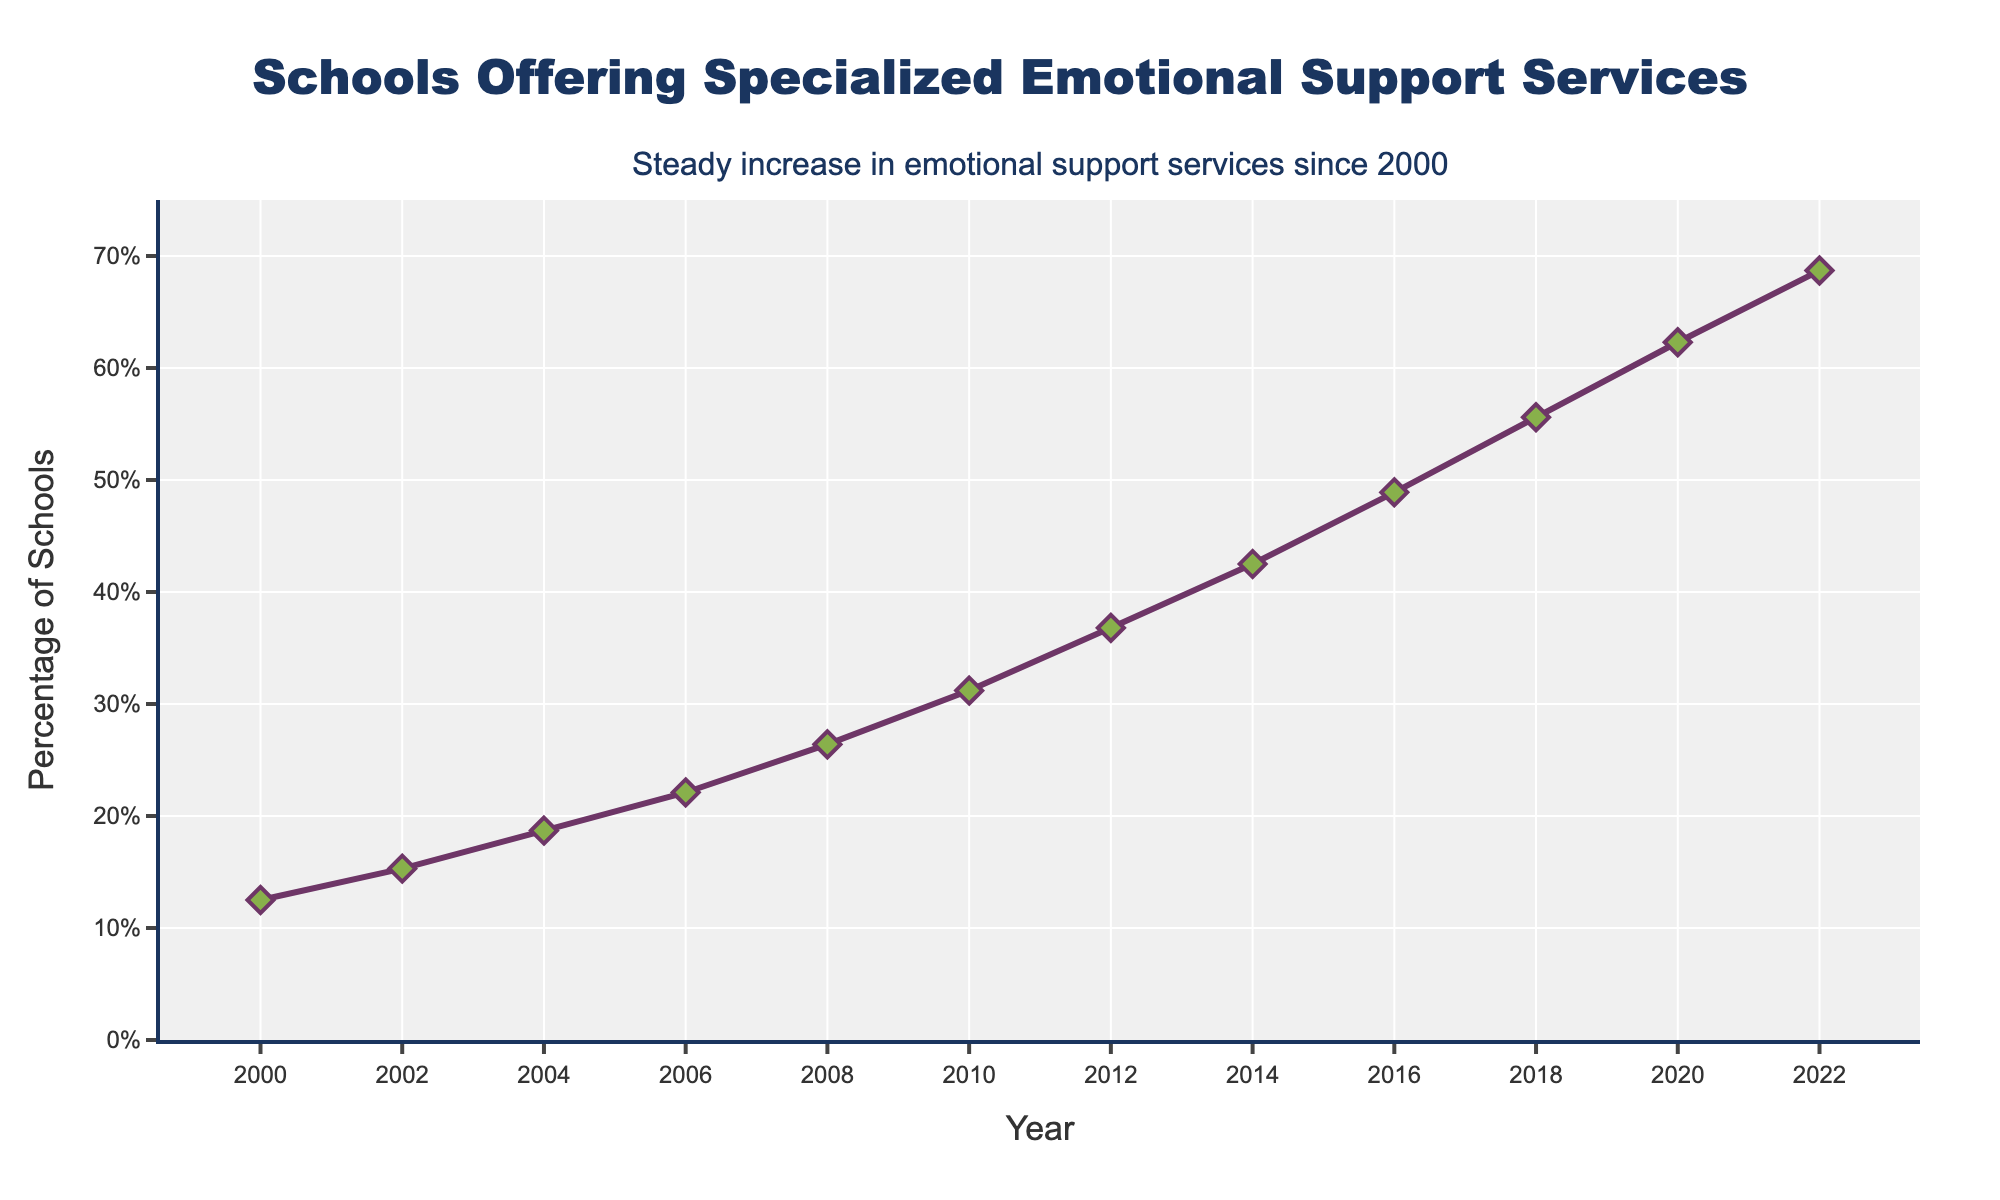What is the percentage of schools offering specialized emotional support services in 2010? Look at the data point corresponding to the year 2010 on the X-axis. The Y-axis value at that point indicates the percentage.
Answer: 31.2% By how many percentage points did the number of schools offering specialized emotional support services increase from 2000 to 2010? Subtract the percentage value in 2000 from the percentage value in 2010. That is 31.2% - 12.5%.
Answer: 18.7% What was the largest year-over-year increase in the percentage of schools offering specialized emotional support services? Identify the years with the largest difference by comparing the percentage values year over year. The largest increase over any two years occurs between 2016 and 2018 (55.6% - 48.9%).
Answer: Between 2016 and 2018 Which year shows the first data point where more than half of the schools offer specialized emotional support services? Locate the point on the graph where the percentage exceeds 50%. This occurs first in 2018.
Answer: 2018 How much did the percentage of schools offering specialized emotional support services increase from 2004 to 2012? Subtract the percentage of schools in 2004 from the percentage in 2012 (36.8% - 18.7%).
Answer: 18.1% What is the difference in the percentage of schools offering specialized emotional support services between 2020 and the first recorded year (2000)? Subtract the percentage value in 2000 from the percentage in 2020. That is 62.3% - 12.5%.
Answer: 49.8% What trend is exhibited by the data in the given timeframe? The line graph shows a continuous upward trend, indicating that the percentage of schools offering specialized emotional support services has been steadily increasing from 2000 to 2022.
Answer: Continuous upward trend How does the percentage increase from 2010 to 2022 compare to the increase from 2000 to 2010? Calculate the percentage increase from 2010 to 2022 (68.7% - 31.2%) and compare with the increase from 2000 to 2010 (31.2% - 12.5%). The difference in percentages for 2010–2022 is 37.5%, while for 2000–2010 it is 18.7%.
Answer: Larger increase between 2010 and 2022 By how much did the support service percentage grow on average per year from 2000 to 2022? Find the total increase from 2000 to 2022 (68.7% - 12.5% = 56.2%) and divide by the number of years, which is 22. Thus, the average growth per year is 56.2% / 22.
Answer: 2.55% per year 